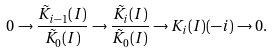<formula> <loc_0><loc_0><loc_500><loc_500>0 \rightarrow \frac { \tilde { K } _ { i - 1 } ( I ) } { \tilde { K } _ { 0 } ( I ) } \rightarrow \frac { \tilde { K } _ { i } ( I ) } { \tilde { K } _ { 0 } ( I ) } \rightarrow K _ { i } ( I ) ( - i ) \rightarrow 0 .</formula> 